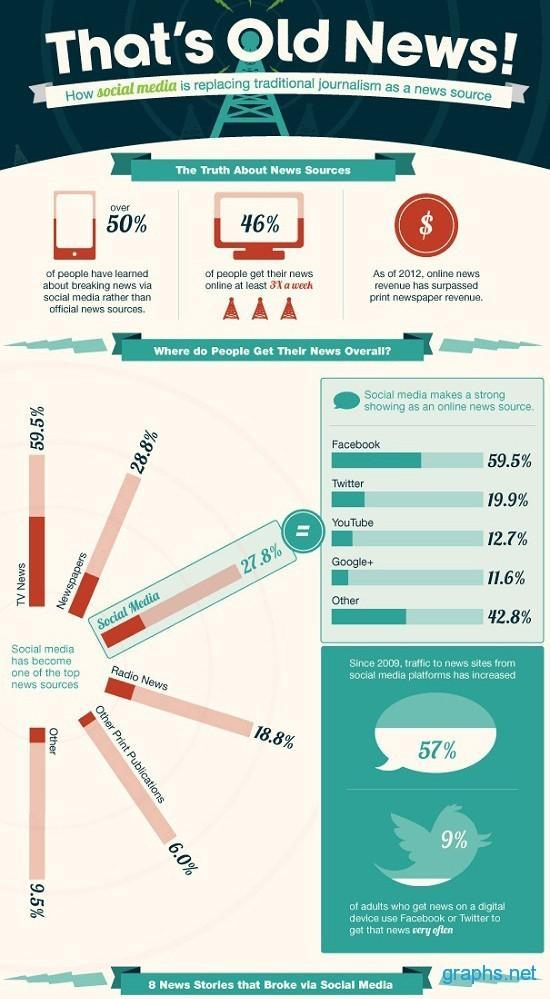How much is the increase in the percentage of usage of online news reading through social media?
Answer the question with a short phrase. 57% Which is the fourth-highest social media platform used for reading news? YouTube What percentage of people read daily information online? 46% Which is the third-highest social media platform used for reading news? Twitter What is the number of breaking news that aired through social media? 8 